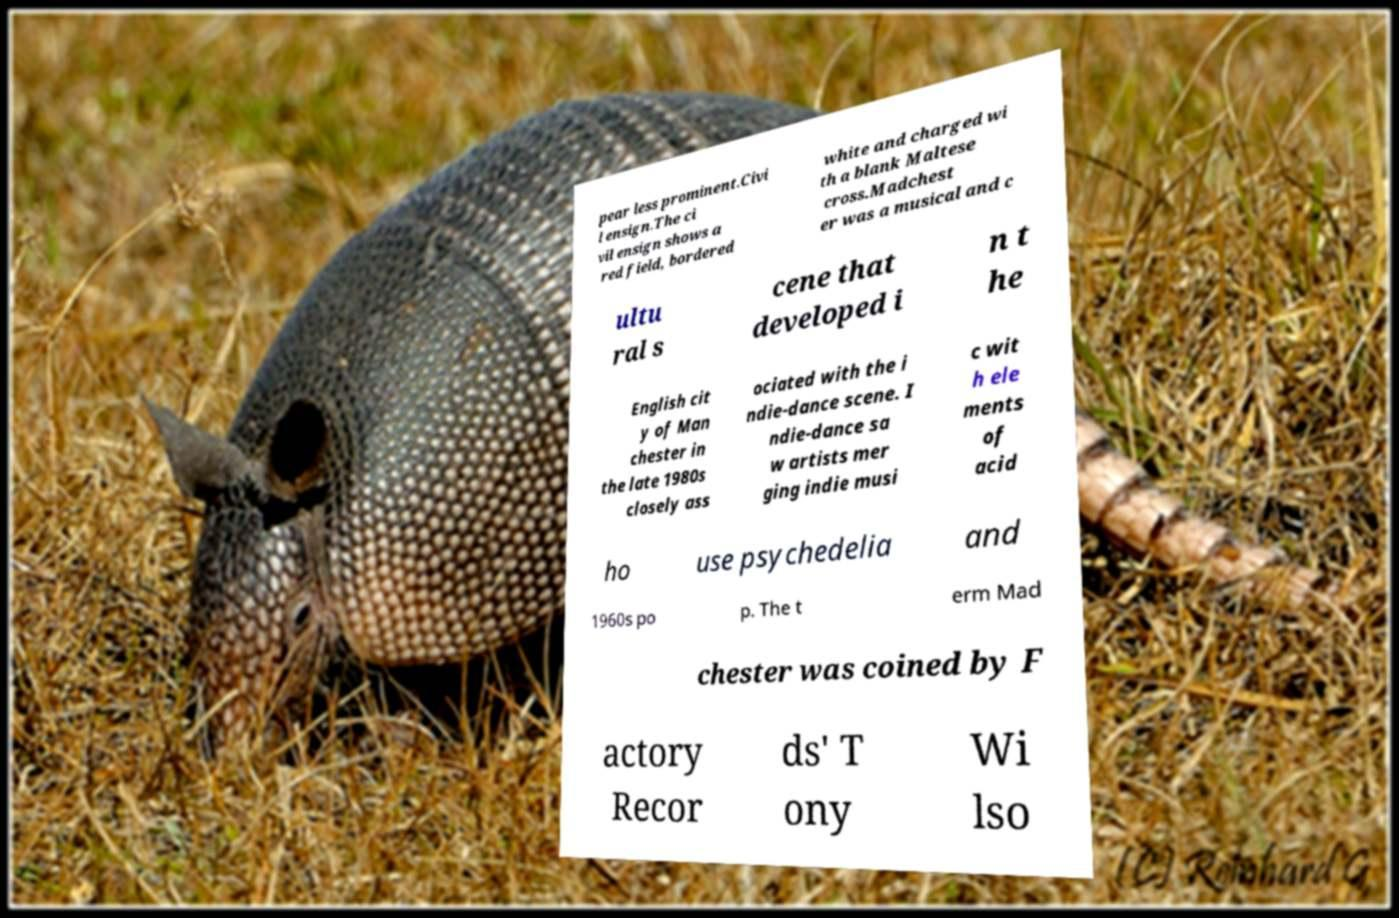Could you assist in decoding the text presented in this image and type it out clearly? pear less prominent.Civi l ensign.The ci vil ensign shows a red field, bordered white and charged wi th a blank Maltese cross.Madchest er was a musical and c ultu ral s cene that developed i n t he English cit y of Man chester in the late 1980s closely ass ociated with the i ndie-dance scene. I ndie-dance sa w artists mer ging indie musi c wit h ele ments of acid ho use psychedelia and 1960s po p. The t erm Mad chester was coined by F actory Recor ds' T ony Wi lso 